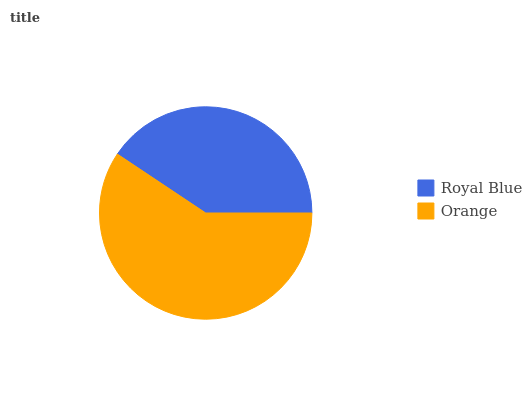Is Royal Blue the minimum?
Answer yes or no. Yes. Is Orange the maximum?
Answer yes or no. Yes. Is Orange the minimum?
Answer yes or no. No. Is Orange greater than Royal Blue?
Answer yes or no. Yes. Is Royal Blue less than Orange?
Answer yes or no. Yes. Is Royal Blue greater than Orange?
Answer yes or no. No. Is Orange less than Royal Blue?
Answer yes or no. No. Is Orange the high median?
Answer yes or no. Yes. Is Royal Blue the low median?
Answer yes or no. Yes. Is Royal Blue the high median?
Answer yes or no. No. Is Orange the low median?
Answer yes or no. No. 